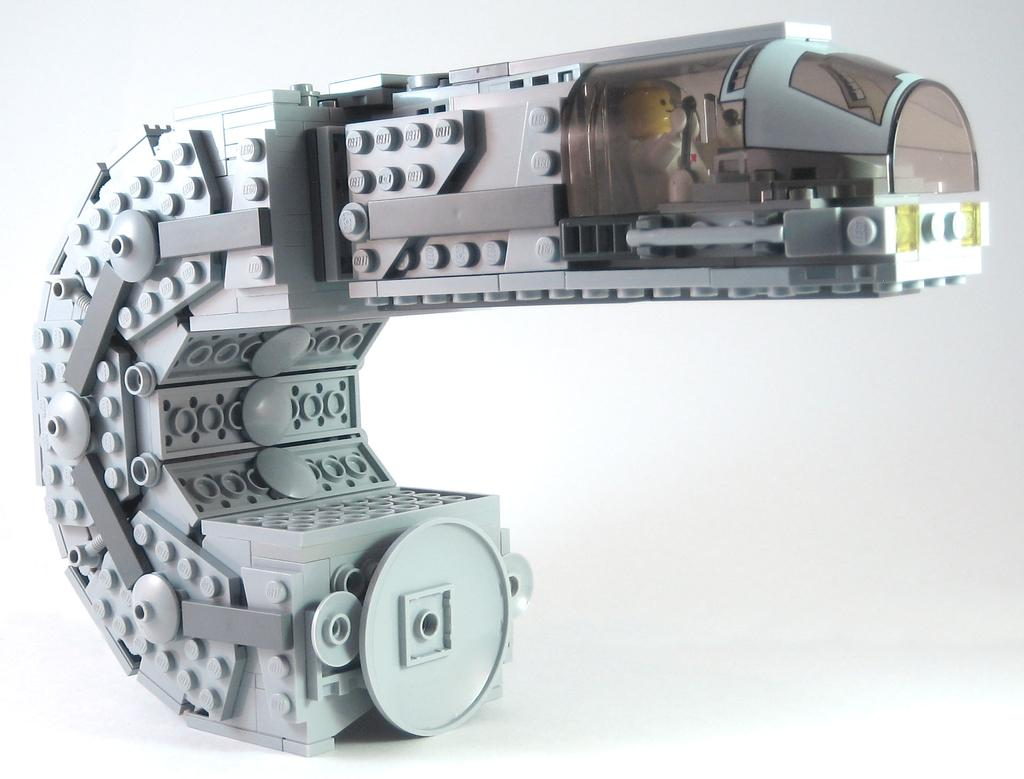What is the main subject or object in the image? There is an object in the center of the image. What type of clover is being waved as a good-bye gesture in the image? There is no clover or good-bye gesture present in the image; it only features an object in the center. 